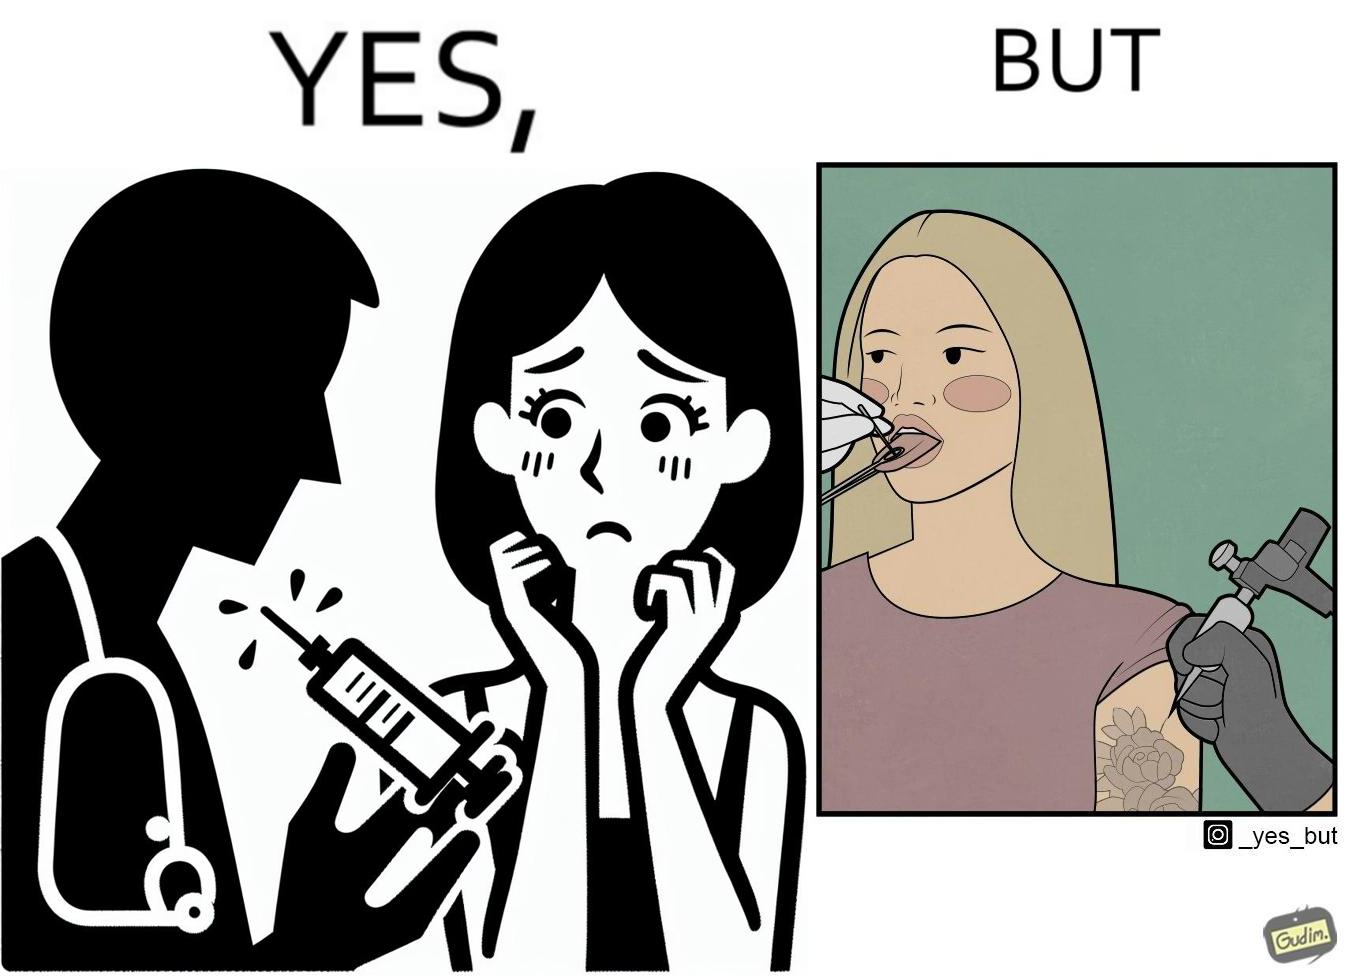Compare the left and right sides of this image. In the left part of the image: The iamge shows a woman scared of the syringe about to be used to inject her with medicine. In the right part of the image: The image shows a woman with her tongue out getting a piercing in her tongue. The image also shows shows the same woman getting tattoed on her left arm at the same time as getting  a piercing. 